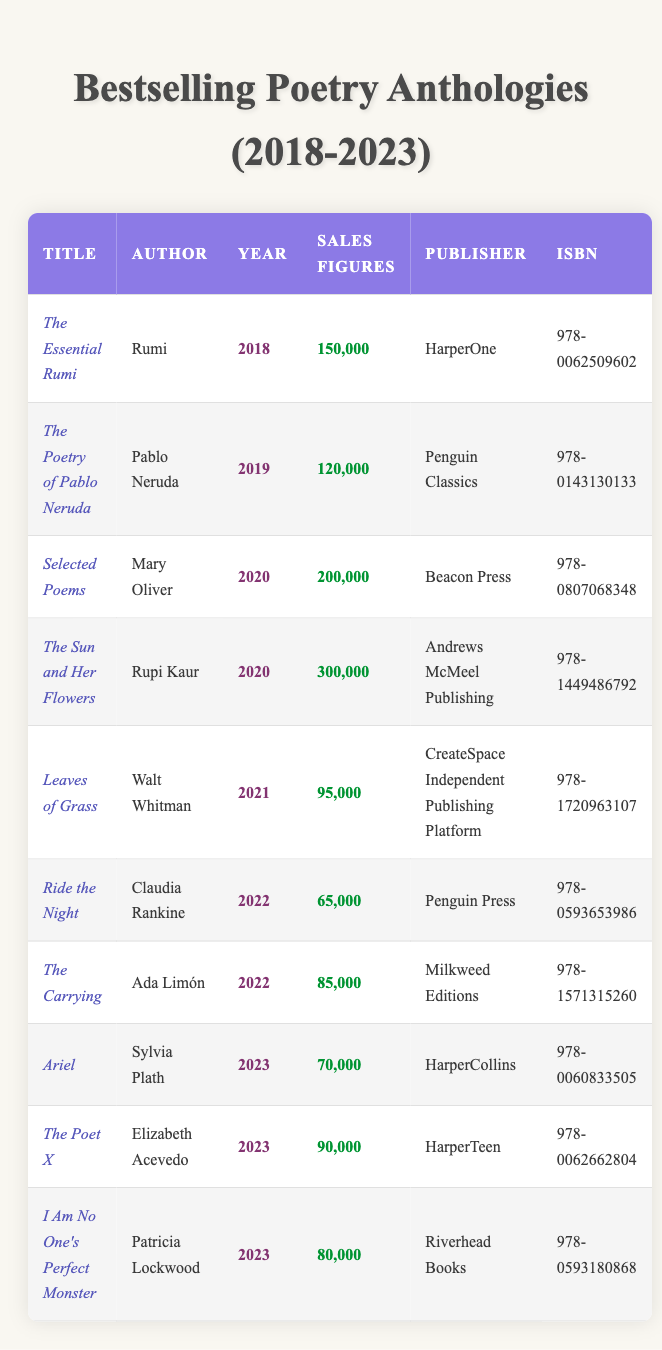What are the sales figures for "The Essential Rumi"? The table lists "The Essential Rumi" with sales figures of 150,000.
Answer: 150,000 Which author had the highest sales in 2020? Referring to the sales figures for 2020, "The Sun and Her Flowers" by Rupi Kaur has the highest sales of 300,000 compared to "Selected Poems" by Mary Oliver, which has 200,000.
Answer: Rupi Kaur Is "Leaves of Grass" from a major publishing house? The publisher for "Leaves of Grass" is CreateSpace Independent Publishing Platform, which is not a major publishing house compared to others in the table.
Answer: No What is the total sales of all anthologies published in 2022? For 2022, the sales figures are 65,000 (Ride the Night) + 85,000 (The Carrying) = 150,000 as the total sales figure for the year.
Answer: 150,000 Which poetry anthology has the lowest sales figures? The table indicates "Ride the Night" by Claudia Rankine with the lowest sales of 65,000.
Answer: 65,000 What is the average sales figure for all anthologies published in 2023? The sales figures for 2023 are 70,000 (Ariel) + 90,000 (The Poet X) + 80,000 (I Am No One's Perfect Monster). The average is (70,000 + 90,000 + 80,000) / 3 = 80,000.
Answer: 80,000 Is "The Poetry of Pablo Neruda" more successful in sales than "Ariel"? "The Poetry of Pablo Neruda" has sales figures of 120,000, while "Ariel" has 70,000, thereby confirming that Neruda's anthology is more successful in sales.
Answer: Yes Which year had the most anthologies listed? The table features anthologies from 2018 to 2023, with 2023 having 3 entries. By comparing, 2020 also has 2 entries, and the remaining years have 1 each. Therefore, 2023 has the most anthologies listed.
Answer: 2023 